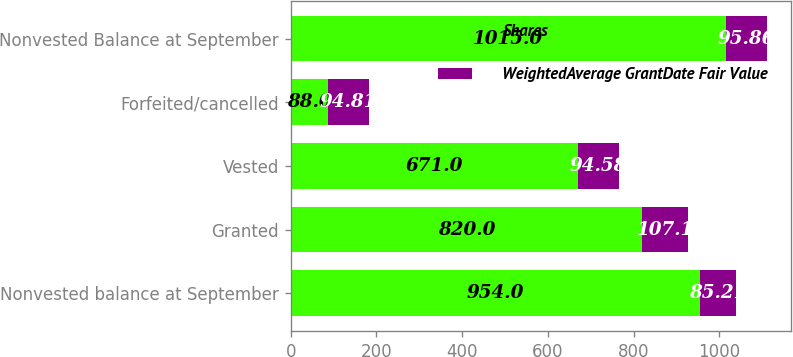Convert chart to OTSL. <chart><loc_0><loc_0><loc_500><loc_500><stacked_bar_chart><ecel><fcel>Nonvested balance at September<fcel>Granted<fcel>Vested<fcel>Forfeited/cancelled<fcel>Nonvested Balance at September<nl><fcel>Shares<fcel>954<fcel>820<fcel>671<fcel>88<fcel>1015<nl><fcel>WeightedAverage GrantDate Fair Value<fcel>85.21<fcel>107.1<fcel>94.58<fcel>94.81<fcel>95.86<nl></chart> 